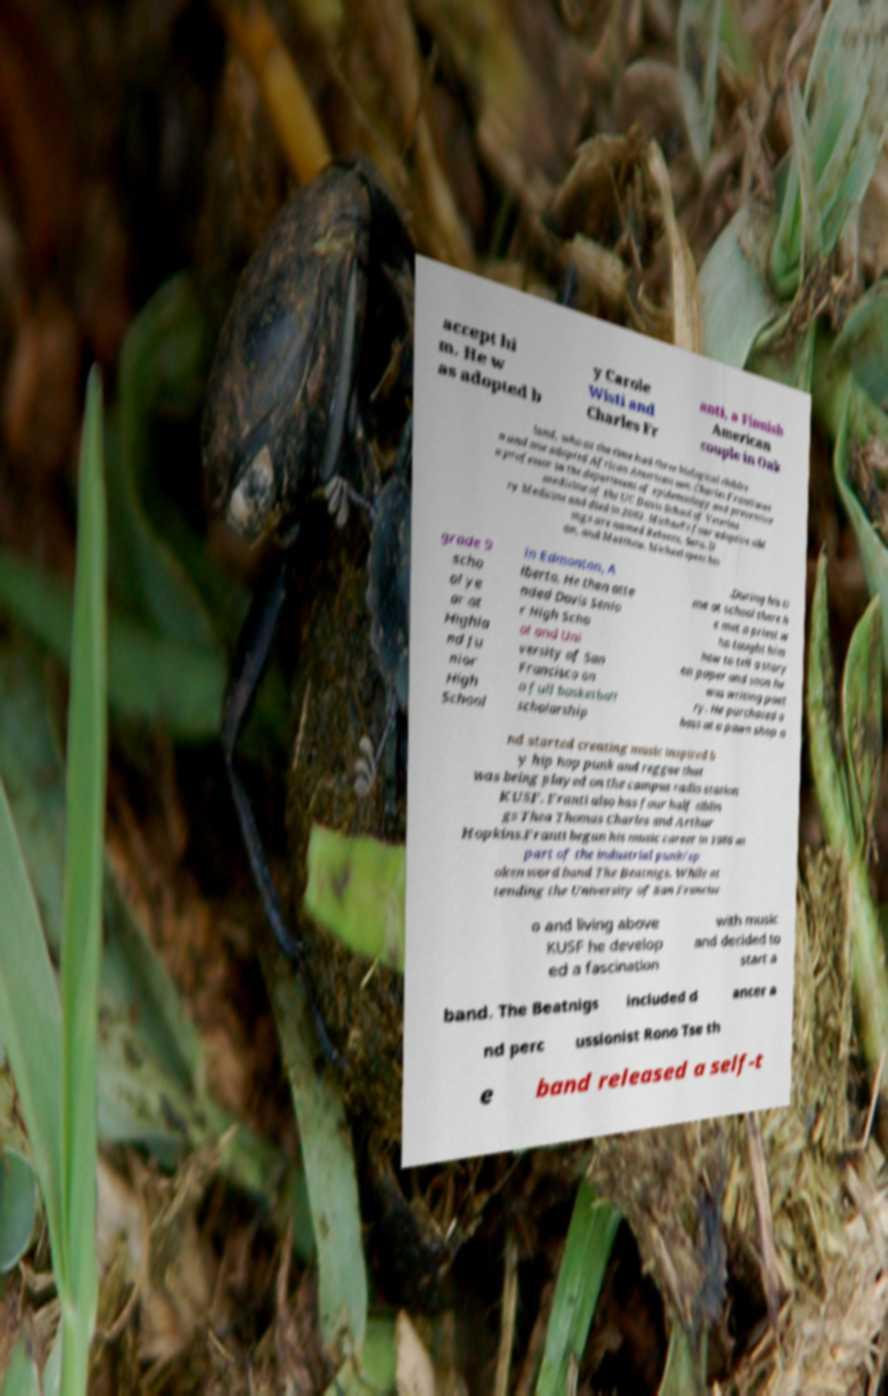Could you assist in decoding the text presented in this image and type it out clearly? accept hi m. He w as adopted b y Carole Wisti and Charles Fr anti, a Finnish American couple in Oak land, who at the time had three biological childre n and one adopted African American son. Charles Franti was a professor in the department of epidemiology and preventive medicine of the UC Davis School of Veterina ry Medicine and died in 2003. Michael's four adoptive sibl ings are named Rebecca, Sara, D an, and Matthew. Michael spent his grade 9 scho ol ye ar at Highla nd Ju nior High School in Edmonton, A lberta. He then atte nded Davis Senio r High Scho ol and Uni versity of San Francisco on a full basketball scholarship .During his ti me at school there h e met a priest w ho taught him how to tell a story on paper and soon he was writing poet ry. He purchased a bass at a pawn shop a nd started creating music inspired b y hip hop punk and reggae that was being played on the campus radio station KUSF. Franti also has four half siblin gs Thea Thomas Charles and Arthur Hopkins.Franti began his music career in 1986 as part of the industrial punk/sp oken word band The Beatnigs. While at tending the University of San Francisc o and living above KUSF he develop ed a fascination with music and decided to start a band. The Beatnigs included d ancer a nd perc ussionist Rono Tse th e band released a self-t 